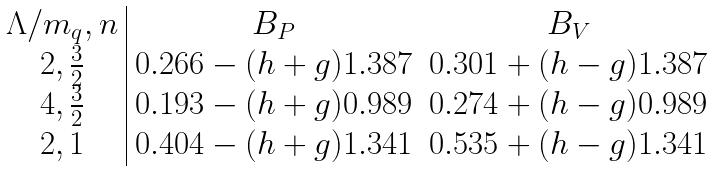Convert formula to latex. <formula><loc_0><loc_0><loc_500><loc_500>\begin{array} { c | c c } \Lambda / { m } _ { q } , n & { B } _ { P } & { B } _ { V } \\ 2 , { \frac { 3 } { 2 } } & 0 . 2 6 6 - ( h + g ) 1 . 3 8 7 & 0 . 3 0 1 + ( h - g ) 1 . 3 8 7 \\ 4 , { \frac { 3 } { 2 } } & 0 . 1 9 3 - ( h + g ) 0 . 9 8 9 & 0 . 2 7 4 + ( h - g ) 0 . 9 8 9 \\ 2 , 1 & 0 . 4 0 4 - ( h + g ) 1 . 3 4 1 & 0 . 5 3 5 + ( h - g ) 1 . 3 4 1 \end{array}</formula> 